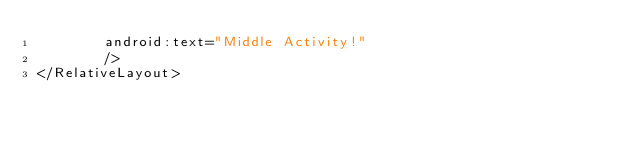<code> <loc_0><loc_0><loc_500><loc_500><_XML_>        android:text="Middle Activity!"
        />
</RelativeLayout>
</code> 